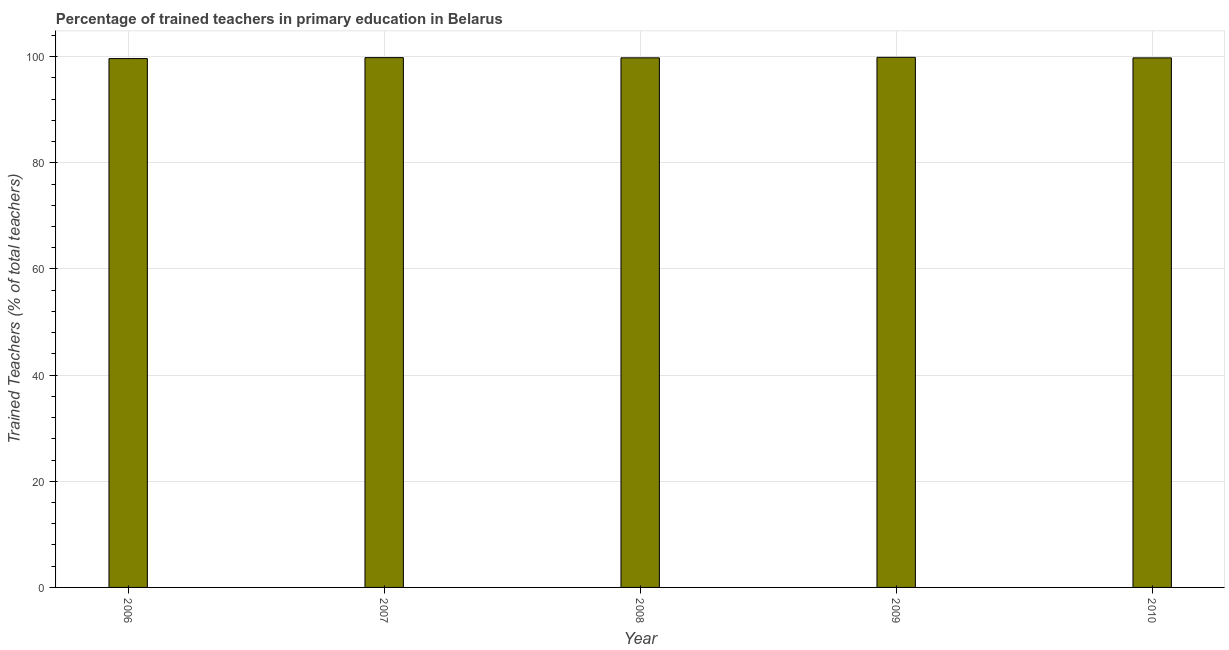What is the title of the graph?
Give a very brief answer. Percentage of trained teachers in primary education in Belarus. What is the label or title of the Y-axis?
Your answer should be very brief. Trained Teachers (% of total teachers). What is the percentage of trained teachers in 2007?
Ensure brevity in your answer.  99.81. Across all years, what is the maximum percentage of trained teachers?
Keep it short and to the point. 99.87. Across all years, what is the minimum percentage of trained teachers?
Ensure brevity in your answer.  99.63. In which year was the percentage of trained teachers minimum?
Give a very brief answer. 2006. What is the sum of the percentage of trained teachers?
Keep it short and to the point. 498.84. What is the difference between the percentage of trained teachers in 2009 and 2010?
Your answer should be very brief. 0.1. What is the average percentage of trained teachers per year?
Ensure brevity in your answer.  99.77. What is the median percentage of trained teachers?
Your answer should be very brief. 99.77. In how many years, is the percentage of trained teachers greater than 92 %?
Provide a short and direct response. 5. What is the ratio of the percentage of trained teachers in 2007 to that in 2010?
Provide a succinct answer. 1. What is the difference between the highest and the second highest percentage of trained teachers?
Your answer should be very brief. 0.06. What is the difference between the highest and the lowest percentage of trained teachers?
Give a very brief answer. 0.24. In how many years, is the percentage of trained teachers greater than the average percentage of trained teachers taken over all years?
Offer a terse response. 3. What is the difference between two consecutive major ticks on the Y-axis?
Provide a short and direct response. 20. What is the Trained Teachers (% of total teachers) of 2006?
Your answer should be very brief. 99.63. What is the Trained Teachers (% of total teachers) of 2007?
Provide a short and direct response. 99.81. What is the Trained Teachers (% of total teachers) in 2008?
Ensure brevity in your answer.  99.77. What is the Trained Teachers (% of total teachers) in 2009?
Keep it short and to the point. 99.87. What is the Trained Teachers (% of total teachers) in 2010?
Make the answer very short. 99.76. What is the difference between the Trained Teachers (% of total teachers) in 2006 and 2007?
Your answer should be very brief. -0.18. What is the difference between the Trained Teachers (% of total teachers) in 2006 and 2008?
Provide a short and direct response. -0.14. What is the difference between the Trained Teachers (% of total teachers) in 2006 and 2009?
Offer a terse response. -0.24. What is the difference between the Trained Teachers (% of total teachers) in 2006 and 2010?
Your response must be concise. -0.13. What is the difference between the Trained Teachers (% of total teachers) in 2007 and 2008?
Ensure brevity in your answer.  0.04. What is the difference between the Trained Teachers (% of total teachers) in 2007 and 2009?
Your answer should be compact. -0.06. What is the difference between the Trained Teachers (% of total teachers) in 2007 and 2010?
Offer a very short reply. 0.05. What is the difference between the Trained Teachers (% of total teachers) in 2008 and 2009?
Your answer should be very brief. -0.09. What is the difference between the Trained Teachers (% of total teachers) in 2008 and 2010?
Give a very brief answer. 0.01. What is the difference between the Trained Teachers (% of total teachers) in 2009 and 2010?
Offer a very short reply. 0.1. What is the ratio of the Trained Teachers (% of total teachers) in 2006 to that in 2007?
Provide a short and direct response. 1. What is the ratio of the Trained Teachers (% of total teachers) in 2006 to that in 2008?
Your response must be concise. 1. What is the ratio of the Trained Teachers (% of total teachers) in 2008 to that in 2010?
Your answer should be very brief. 1. What is the ratio of the Trained Teachers (% of total teachers) in 2009 to that in 2010?
Your answer should be compact. 1. 